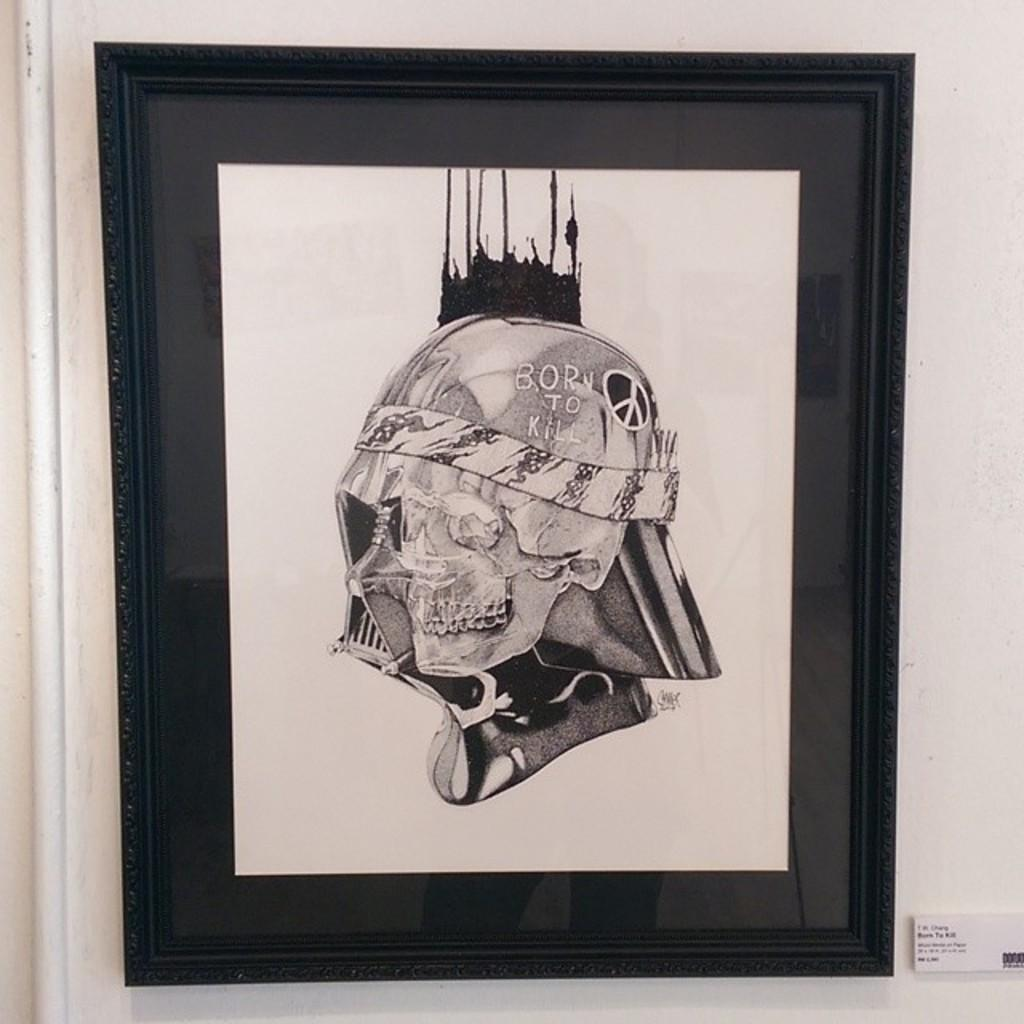What is the color of the photo frame in the image? The photo frame in the image is black. What is displayed inside the photo frame? The photo frame contains a painting of a skull. Are there any additional details on the painting? Yes, the painting has some designs on it. What phrase is written on the painting? The phrase "born to kill" is written on the painting. What type of vase can be seen in the image? There is no vase present in the image. What game is being played in the image? There is no game being played in the image. 